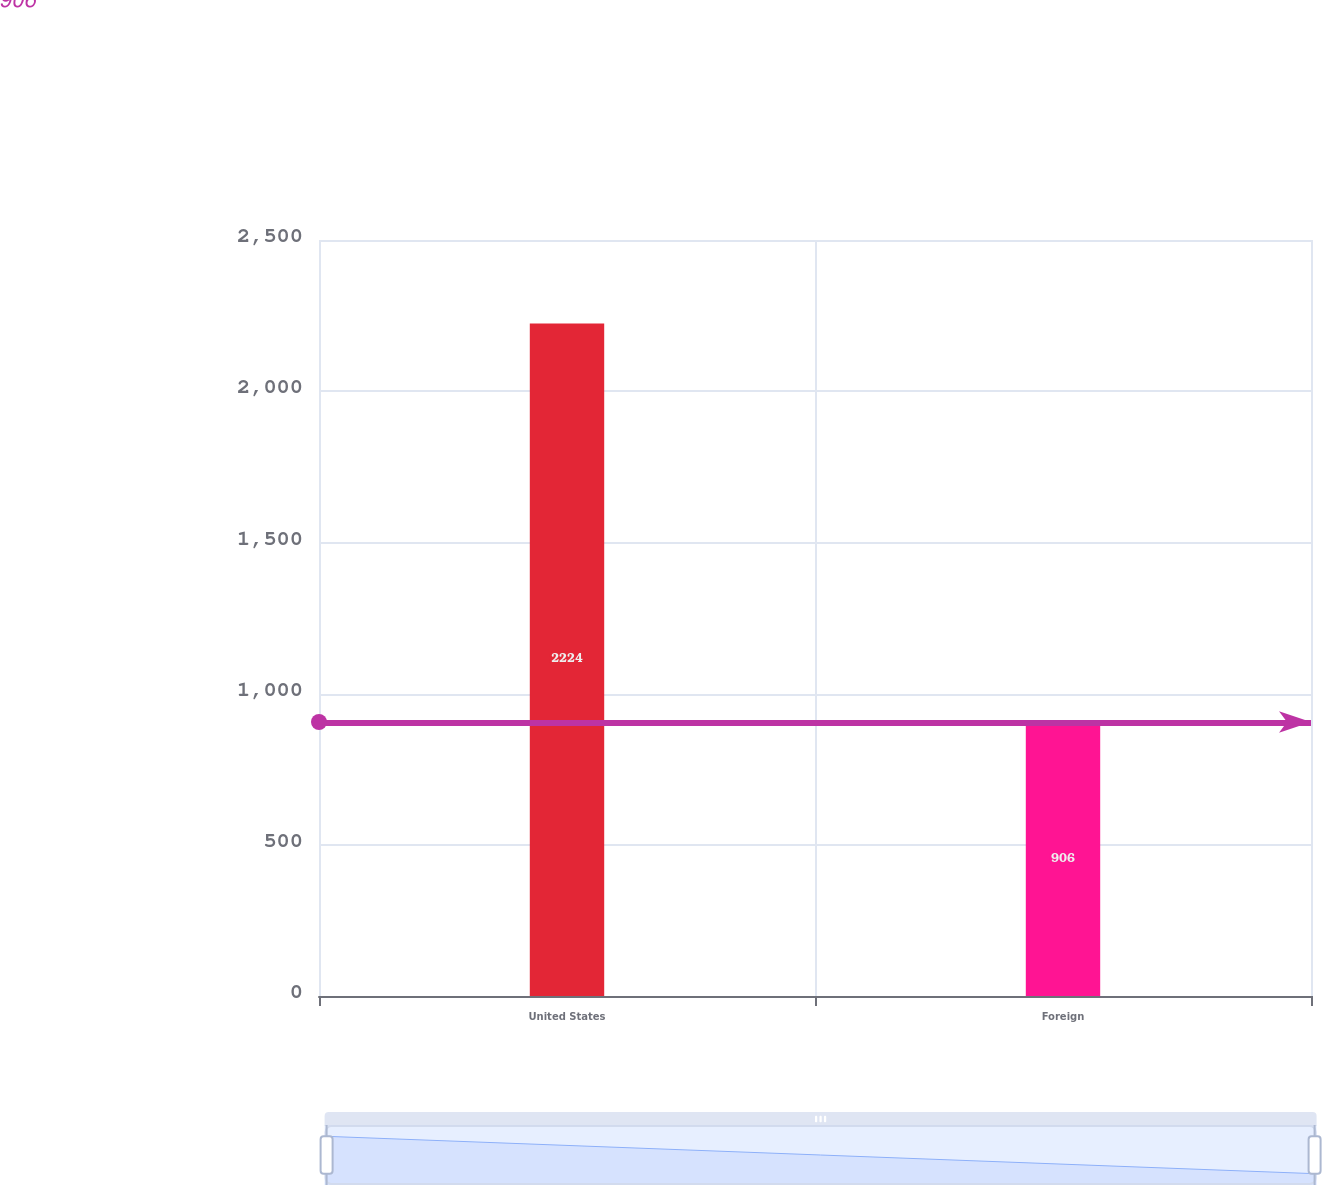Convert chart. <chart><loc_0><loc_0><loc_500><loc_500><bar_chart><fcel>United States<fcel>Foreign<nl><fcel>2224<fcel>906<nl></chart> 